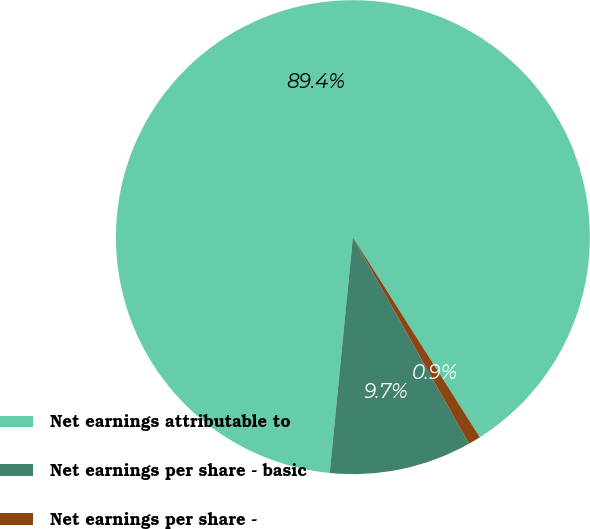Convert chart to OTSL. <chart><loc_0><loc_0><loc_500><loc_500><pie_chart><fcel>Net earnings attributable to<fcel>Net earnings per share - basic<fcel>Net earnings per share -<nl><fcel>89.44%<fcel>9.71%<fcel>0.85%<nl></chart> 